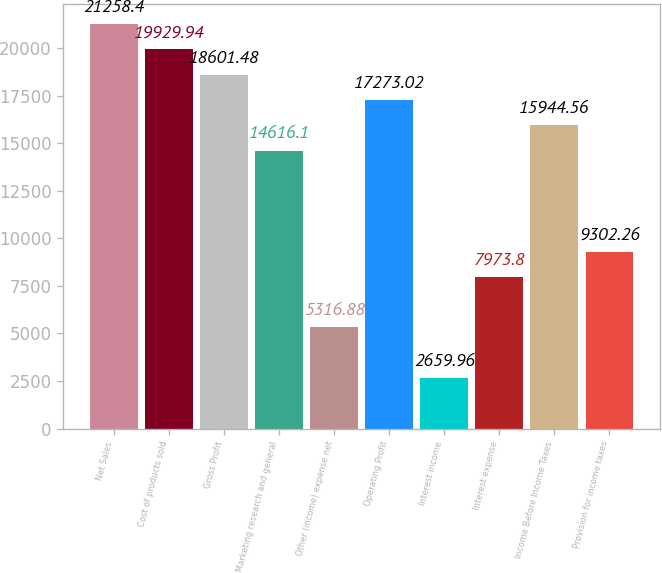<chart> <loc_0><loc_0><loc_500><loc_500><bar_chart><fcel>Net Sales<fcel>Cost of products sold<fcel>Gross Profit<fcel>Marketing research and general<fcel>Other (income) expense net<fcel>Operating Profit<fcel>Interest income<fcel>Interest expense<fcel>Income Before Income Taxes<fcel>Provision for income taxes<nl><fcel>21258.4<fcel>19929.9<fcel>18601.5<fcel>14616.1<fcel>5316.88<fcel>17273<fcel>2659.96<fcel>7973.8<fcel>15944.6<fcel>9302.26<nl></chart> 